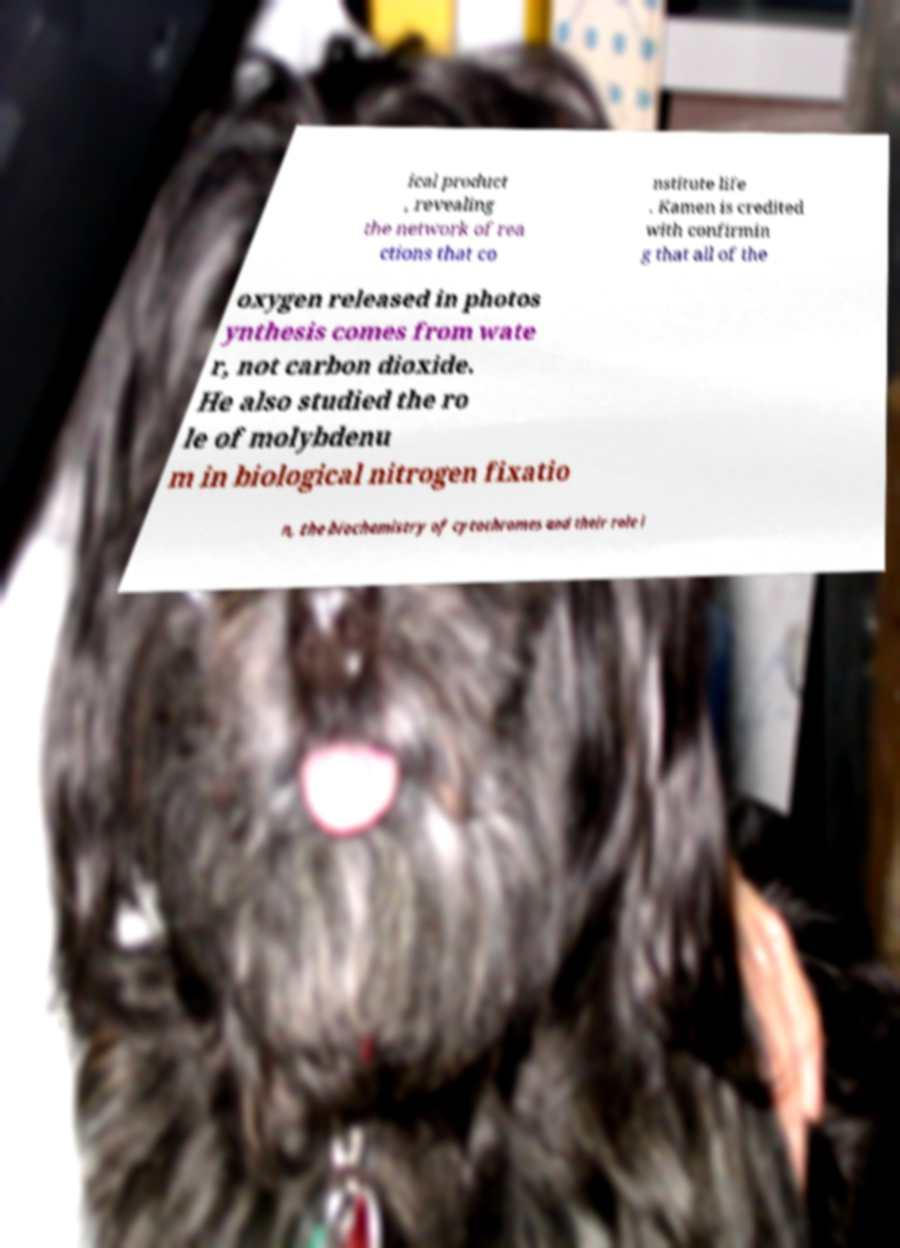There's text embedded in this image that I need extracted. Can you transcribe it verbatim? ical product , revealing the network of rea ctions that co nstitute life . Kamen is credited with confirmin g that all of the oxygen released in photos ynthesis comes from wate r, not carbon dioxide. He also studied the ro le of molybdenu m in biological nitrogen fixatio n, the biochemistry of cytochromes and their role i 